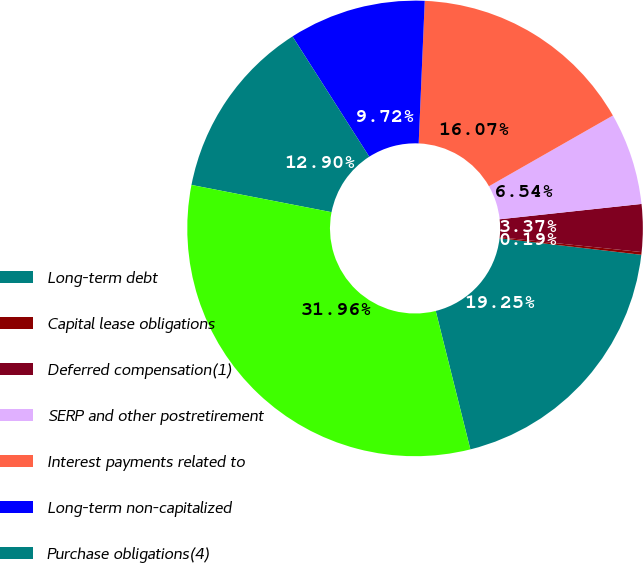Convert chart. <chart><loc_0><loc_0><loc_500><loc_500><pie_chart><fcel>Long-term debt<fcel>Capital lease obligations<fcel>Deferred compensation(1)<fcel>SERP and other postretirement<fcel>Interest payments related to<fcel>Long-term non-capitalized<fcel>Purchase obligations(4)<fcel>Total contractual cash<nl><fcel>19.25%<fcel>0.19%<fcel>3.37%<fcel>6.54%<fcel>16.07%<fcel>9.72%<fcel>12.9%<fcel>31.96%<nl></chart> 